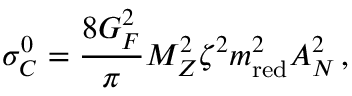<formula> <loc_0><loc_0><loc_500><loc_500>\sigma _ { C } ^ { 0 } = \frac { 8 G _ { F } ^ { 2 } } { \pi } M _ { Z } ^ { 2 } \zeta ^ { 2 } m _ { r e d } ^ { 2 } A _ { N } ^ { 2 } \, ,</formula> 